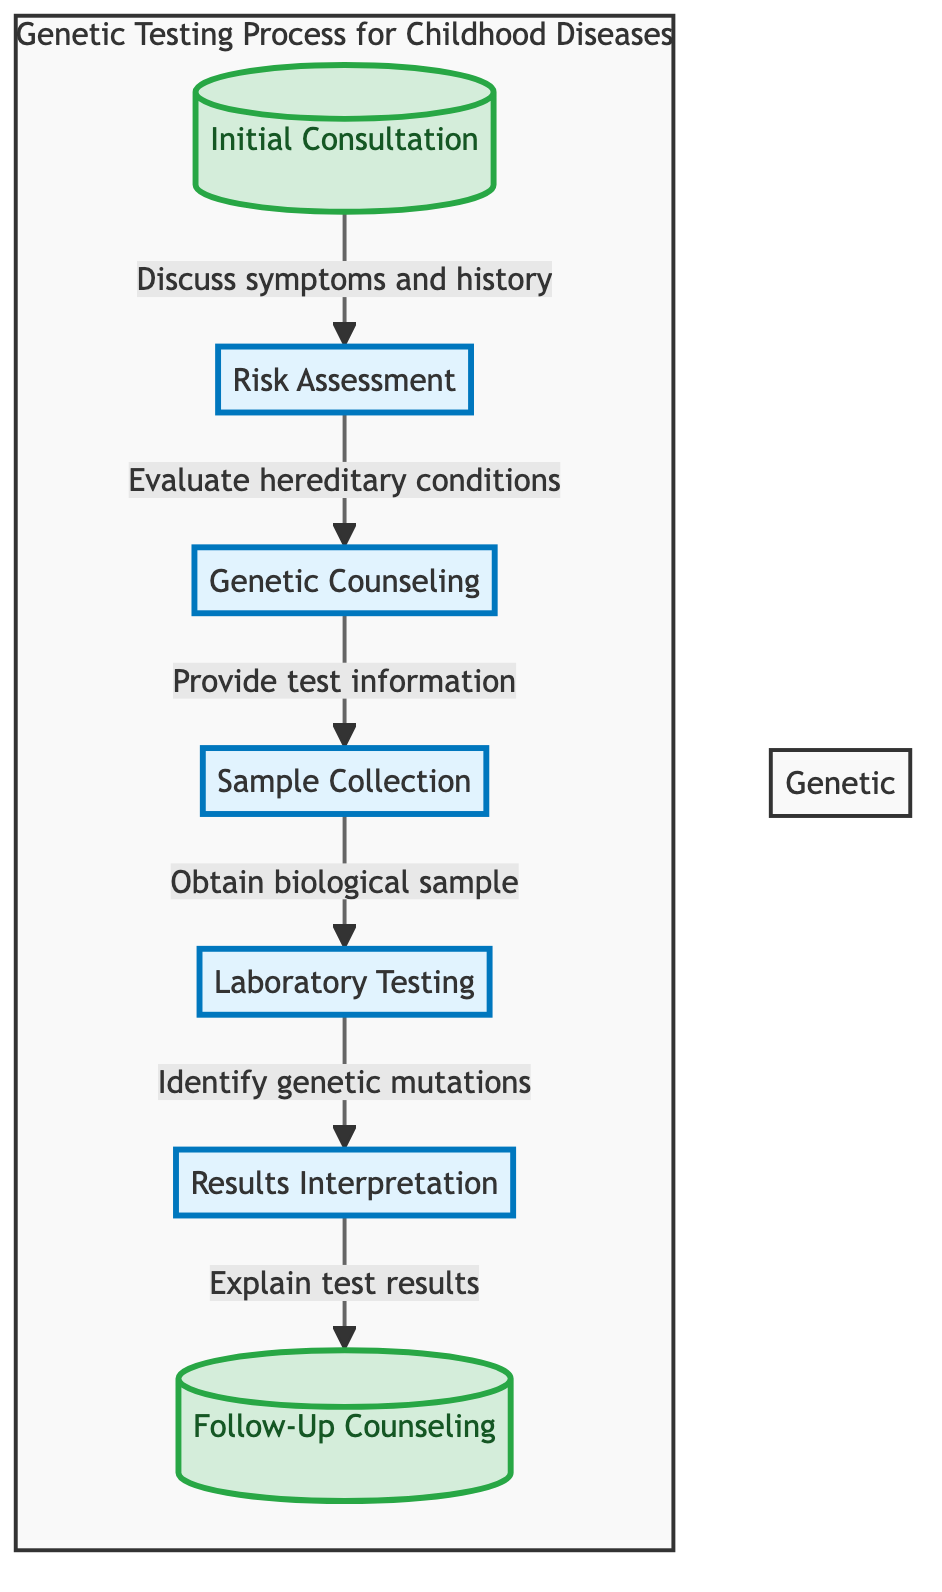What is the first step in the genetic testing process? The diagram starts with the "Initial Consultation" which is the first step listed in the flow chart.
Answer: Initial Consultation How many main steps are there in the genetic testing process? The flow chart outlines seven steps from initial consultation to follow-up counseling, which can be counted in the diagram.
Answer: Seven What is the result of the "Laboratory Testing" step? The "Laboratory Testing" step leads to the identification of genetic mutations as described in the diagram.
Answer: Identify genetic mutations Which step follows "Genetic Counseling"? According to the diagram, the step that follows "Genetic Counseling" is "Sample Collection." This can be deduced by following the arrows in the flow chart.
Answer: Sample Collection What is the purpose of "Results Interpretation"? The purpose of "Results Interpretation" is to explain the test results, as indicated by the corresponding arrow that leads to this step in the flow chart.
Answer: Explain test results Which step takes place after "Sample Collection"? Following the flow of the diagram, after "Sample Collection," the next step is "Laboratory Testing", as indicated by the directional arrow.
Answer: Laboratory Testing What type of biological sample is collected during the "Sample Collection" step? The diagram specifies that biological samples such as blood, saliva, or cheek swab are obtained during this step and are explicitly listed.
Answer: Blood, saliva, or cheek swab What does "Follow-Up Counseling" involve? The flow chart states that "Follow-Up Counseling" involves discussing outcomes and potential management options or treatments as described in the diagram.
Answer: Discussing outcomes and potential management options or treatments Which step directly follows the "Risk Assessment"? According to the diagram, "Genetic Counseling" is the step that directly follows "Risk Assessment", as indicated by the flow of arrows.
Answer: Genetic Counseling 